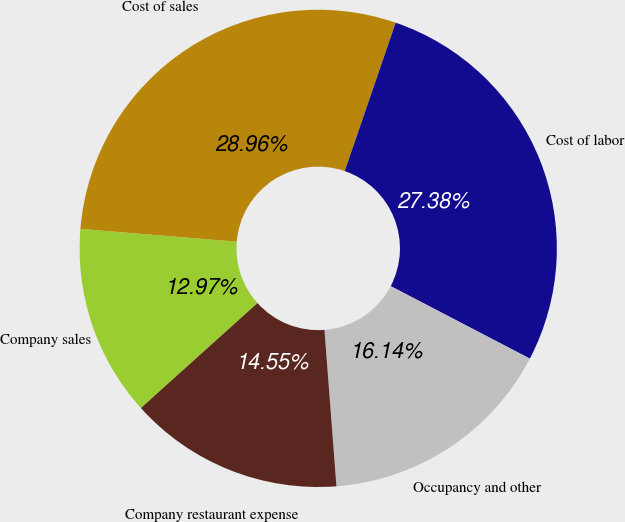Convert chart. <chart><loc_0><loc_0><loc_500><loc_500><pie_chart><fcel>Company sales<fcel>Cost of sales<fcel>Cost of labor<fcel>Occupancy and other<fcel>Company restaurant expense<nl><fcel>12.97%<fcel>28.96%<fcel>27.38%<fcel>16.14%<fcel>14.55%<nl></chart> 